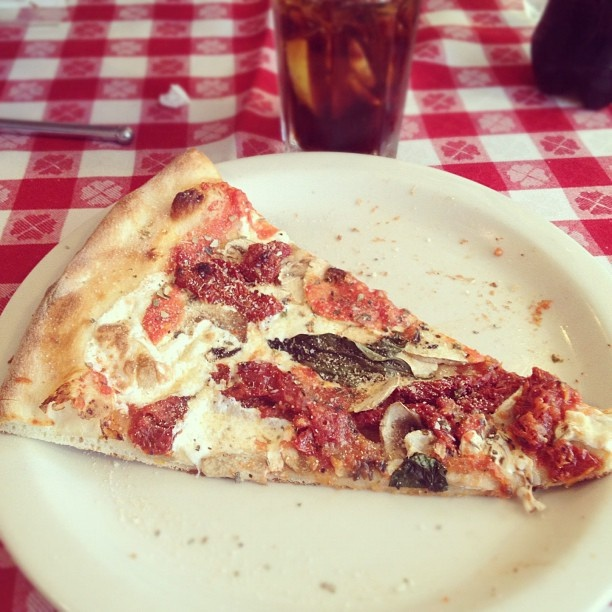Describe the objects in this image and their specific colors. I can see pizza in darkgray, tan, and brown tones, dining table in brown, maroon, and lightpink tones, and cup in darkgray, maroon, and brown tones in this image. 